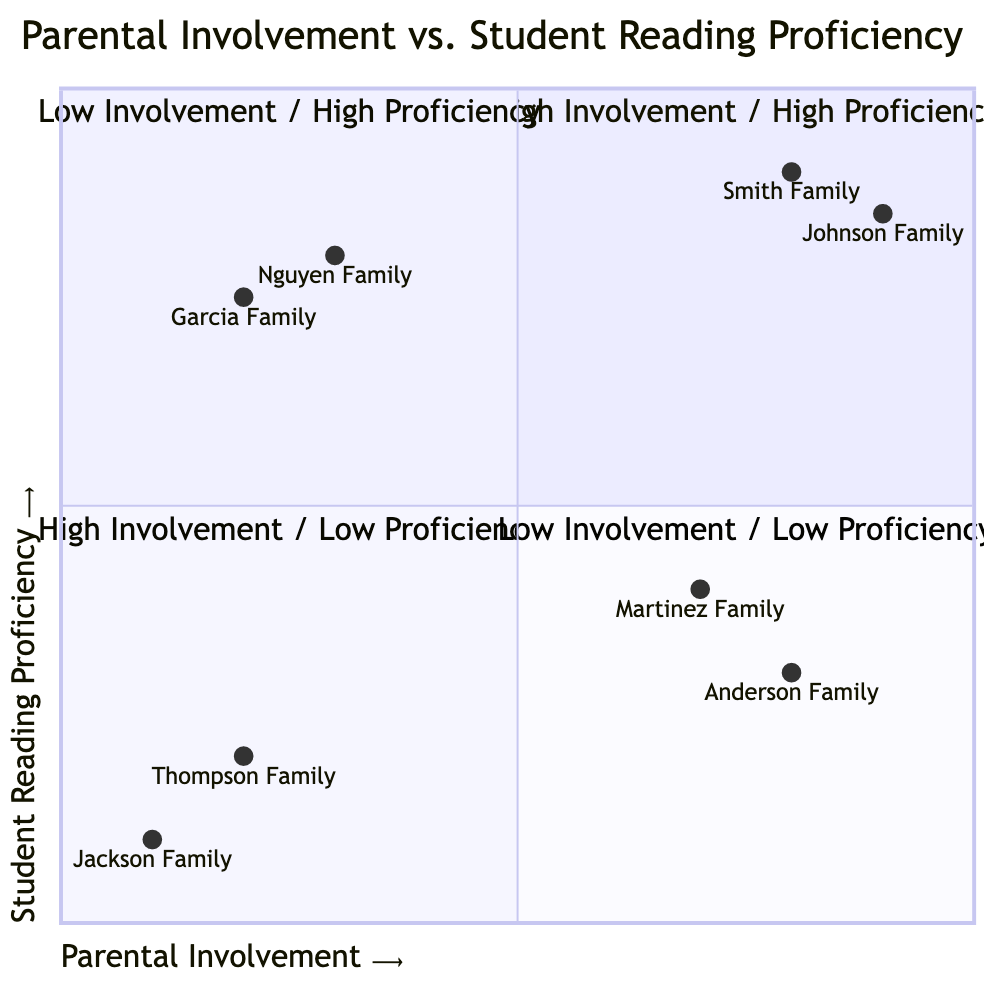What is the number of families in the High Involvement / High Proficiency quadrant? The High Involvement / High Proficiency quadrant (Q1) has two families listed: Smith Family and Johnson Family.
Answer: 2 Which family has the highest level of parental involvement? Upon reviewing the families' data points, the Johnson Family is positioned highest on the X-axis (0.9) indicating the highest level of parental involvement.
Answer: Johnson Family What is the reading proficiency score of the Thompson Family? The Thompson Family's data point shows a reading proficiency score of 0.2 on the Y-axis in the Low Involvement / Low Proficiency quadrant (Q4).
Answer: 0.2 Are there any families in the Low Involvement / High Proficiency quadrant? Upon inspecting the diagram, there are two families in the Low Involvement / High Proficiency quadrant (Q2): Nguyen Family and Garcia Family.
Answer: Yes Which family exhibits high parental involvement but low reading proficiency? The Martinez Family is positioned in the High Involvement / Low Proficiency quadrant (Q3), showing high parental involvement with a reading proficiency score of 0.4 on the Y-axis.
Answer: Martinez Family What does the Low Involvement / Low Proficiency quadrant indicate? The Low Involvement / Low Proficiency quadrant (Q4) reflects a direct correlation between low parental engagement and low student reading proficiency, revealing the urgency for additional support and resources.
Answer: Critical need for support How many families have high reading proficiency but low parental involvement? Two families are in the Low Involvement / High Proficiency quadrant (Q2), which are Nguyen Family and Garcia Family.
Answer: 2 In which quadrant is the Anderson Family located? The Anderson Family is located in the High Involvement / Low Proficiency quadrant (Q3), reflecting their strong parental participation but lack of student reading proficiency.
Answer: High Involvement / Low Proficiency What is the reading proficiency score of the Jackson Family? The Jackson Family has a reading proficiency score of 0.1, which places them in the Low Involvement / Low Proficiency quadrant (Q4).
Answer: 0.1 